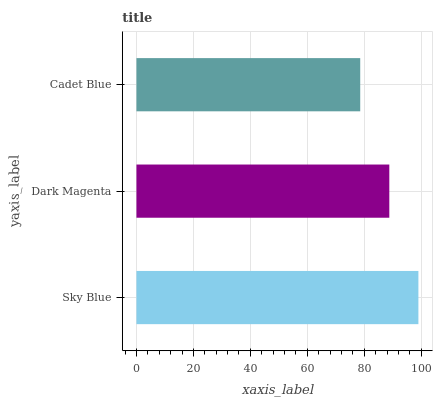Is Cadet Blue the minimum?
Answer yes or no. Yes. Is Sky Blue the maximum?
Answer yes or no. Yes. Is Dark Magenta the minimum?
Answer yes or no. No. Is Dark Magenta the maximum?
Answer yes or no. No. Is Sky Blue greater than Dark Magenta?
Answer yes or no. Yes. Is Dark Magenta less than Sky Blue?
Answer yes or no. Yes. Is Dark Magenta greater than Sky Blue?
Answer yes or no. No. Is Sky Blue less than Dark Magenta?
Answer yes or no. No. Is Dark Magenta the high median?
Answer yes or no. Yes. Is Dark Magenta the low median?
Answer yes or no. Yes. Is Cadet Blue the high median?
Answer yes or no. No. Is Sky Blue the low median?
Answer yes or no. No. 